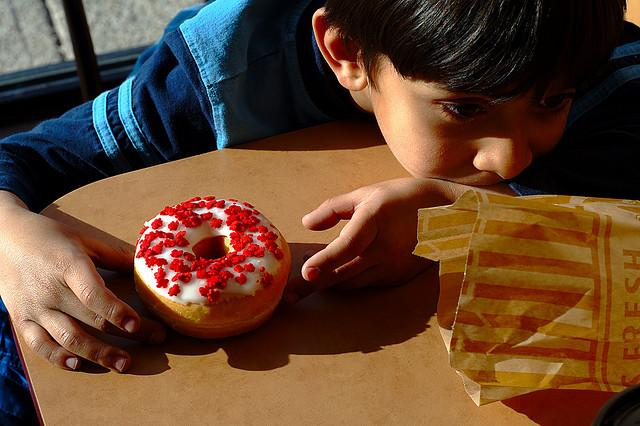When did the restaurant make this donut?

Choices:
A) same day
B) month before
C) week before
D) day before same day 